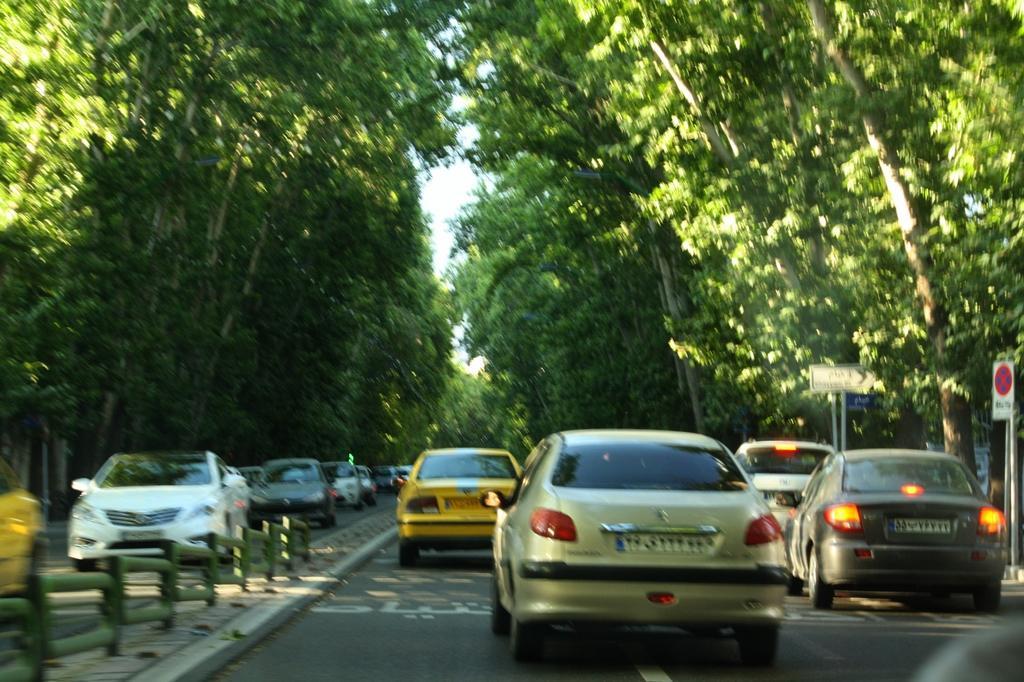Can you describe this image briefly? In this image, we can see few vehicles are on the road. Here we can see rod fencing and sign boards with poles. Background there are so many trees and sky. 